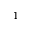<formula> <loc_0><loc_0><loc_500><loc_500>1</formula> 